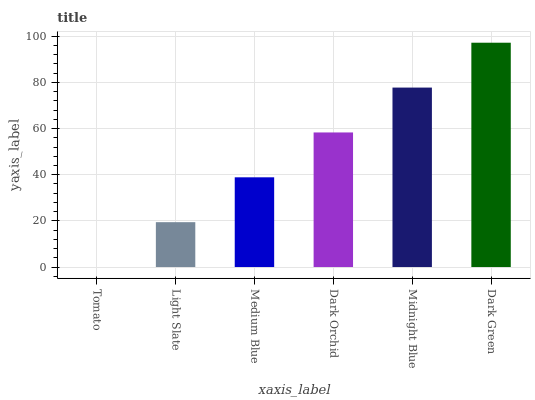Is Light Slate the minimum?
Answer yes or no. No. Is Light Slate the maximum?
Answer yes or no. No. Is Light Slate greater than Tomato?
Answer yes or no. Yes. Is Tomato less than Light Slate?
Answer yes or no. Yes. Is Tomato greater than Light Slate?
Answer yes or no. No. Is Light Slate less than Tomato?
Answer yes or no. No. Is Dark Orchid the high median?
Answer yes or no. Yes. Is Medium Blue the low median?
Answer yes or no. Yes. Is Medium Blue the high median?
Answer yes or no. No. Is Tomato the low median?
Answer yes or no. No. 